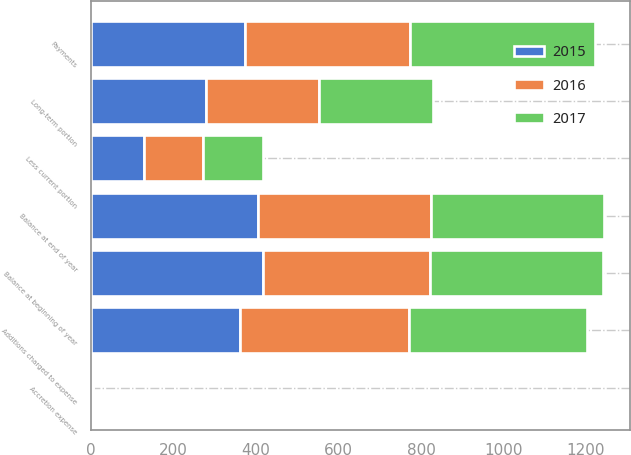Convert chart to OTSL. <chart><loc_0><loc_0><loc_500><loc_500><stacked_bar_chart><ecel><fcel>Balance at beginning of year<fcel>Additions charged to expense<fcel>Payments<fcel>Accretion expense<fcel>Balance at end of year<fcel>Less current portion<fcel>Long-term portion<nl><fcel>2017<fcel>418.5<fcel>432.9<fcel>448<fcel>1.2<fcel>420.2<fcel>144.8<fcel>275.4<nl><fcel>2016<fcel>405.8<fcel>410.3<fcel>400.5<fcel>1.5<fcel>418.5<fcel>143.9<fcel>274.6<nl><fcel>2015<fcel>416.6<fcel>360.4<fcel>373.1<fcel>1.9<fcel>405.8<fcel>127.7<fcel>278.1<nl></chart> 